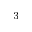<formula> <loc_0><loc_0><loc_500><loc_500>^ { - 3 }</formula> 